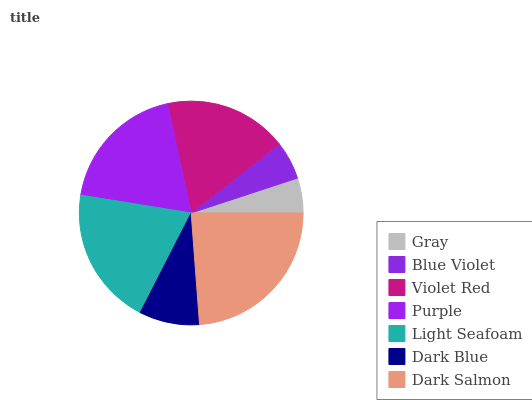Is Gray the minimum?
Answer yes or no. Yes. Is Dark Salmon the maximum?
Answer yes or no. Yes. Is Blue Violet the minimum?
Answer yes or no. No. Is Blue Violet the maximum?
Answer yes or no. No. Is Blue Violet greater than Gray?
Answer yes or no. Yes. Is Gray less than Blue Violet?
Answer yes or no. Yes. Is Gray greater than Blue Violet?
Answer yes or no. No. Is Blue Violet less than Gray?
Answer yes or no. No. Is Violet Red the high median?
Answer yes or no. Yes. Is Violet Red the low median?
Answer yes or no. Yes. Is Dark Blue the high median?
Answer yes or no. No. Is Dark Salmon the low median?
Answer yes or no. No. 